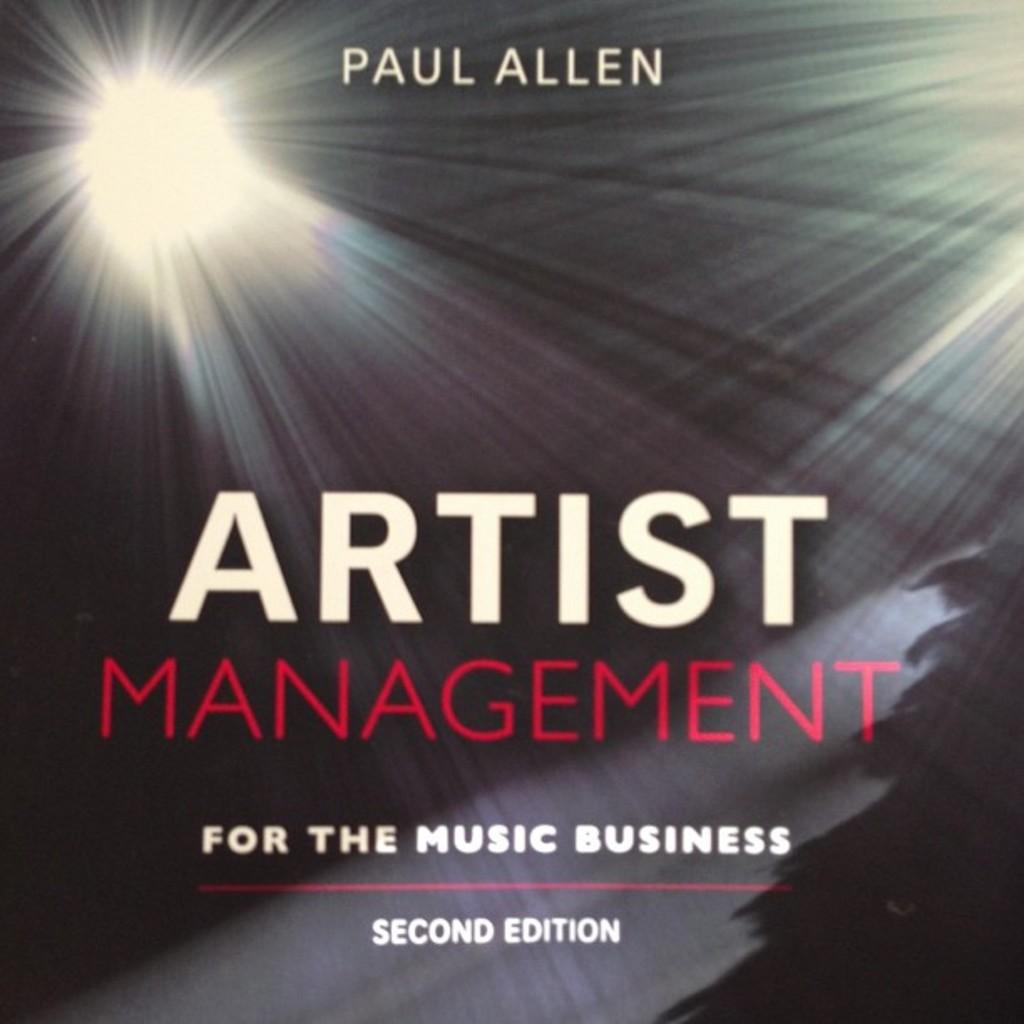<image>
Provide a brief description of the given image. A book with colorful lights about the music business. 